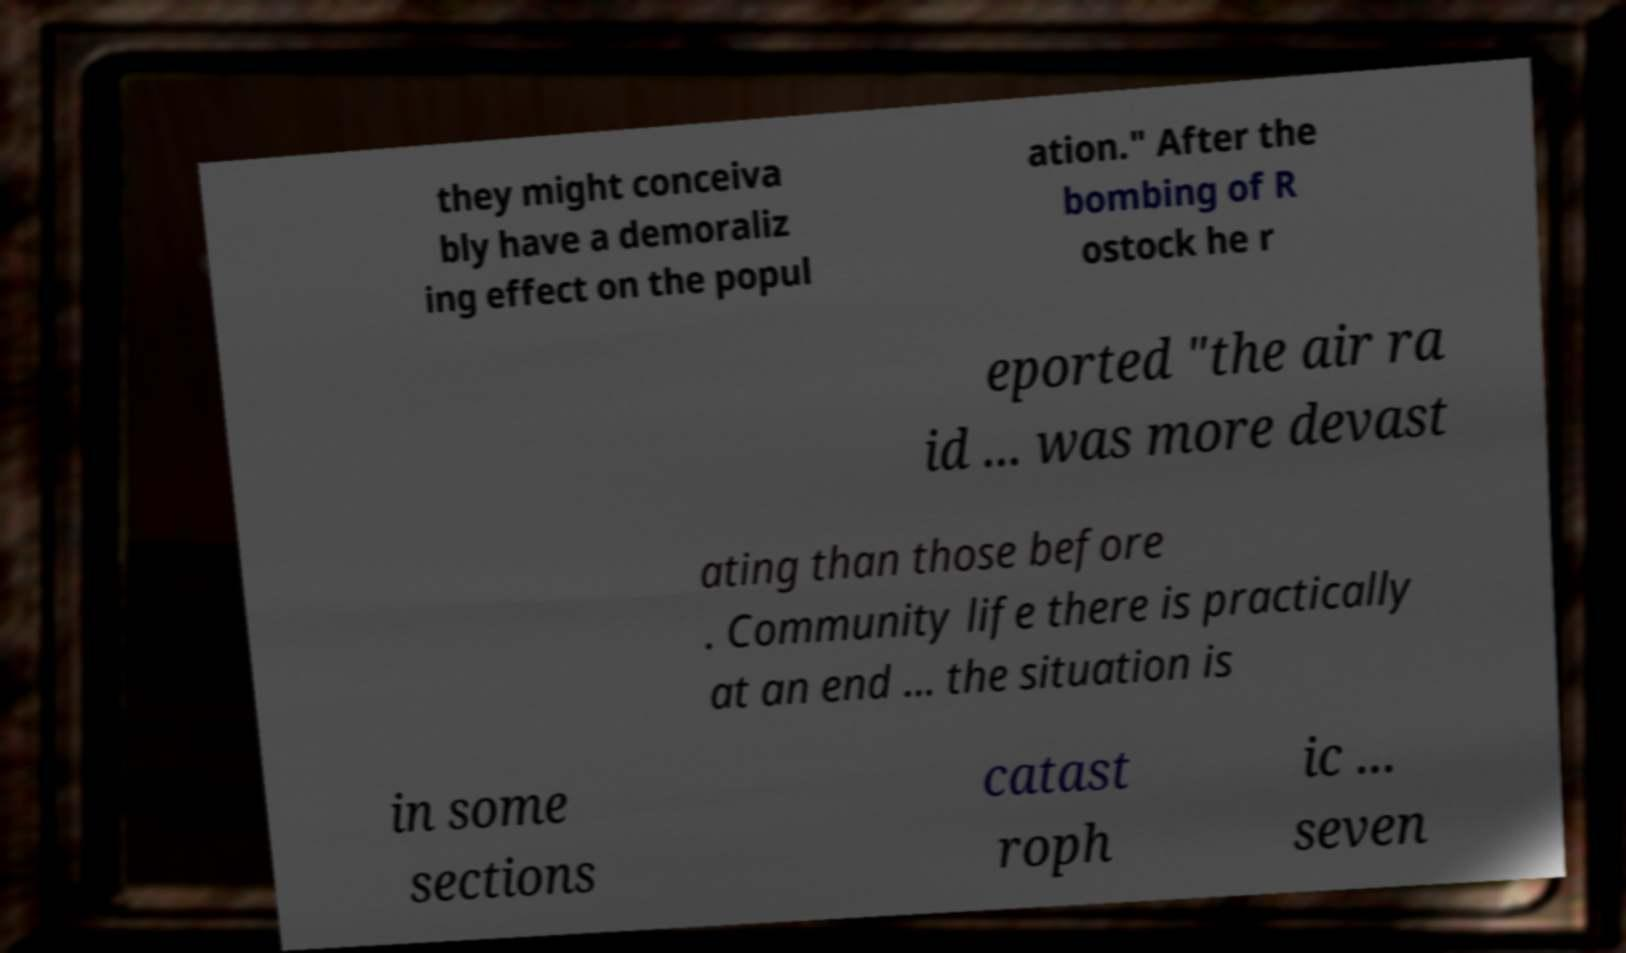For documentation purposes, I need the text within this image transcribed. Could you provide that? they might conceiva bly have a demoraliz ing effect on the popul ation." After the bombing of R ostock he r eported "the air ra id ... was more devast ating than those before . Community life there is practically at an end ... the situation is in some sections catast roph ic ... seven 